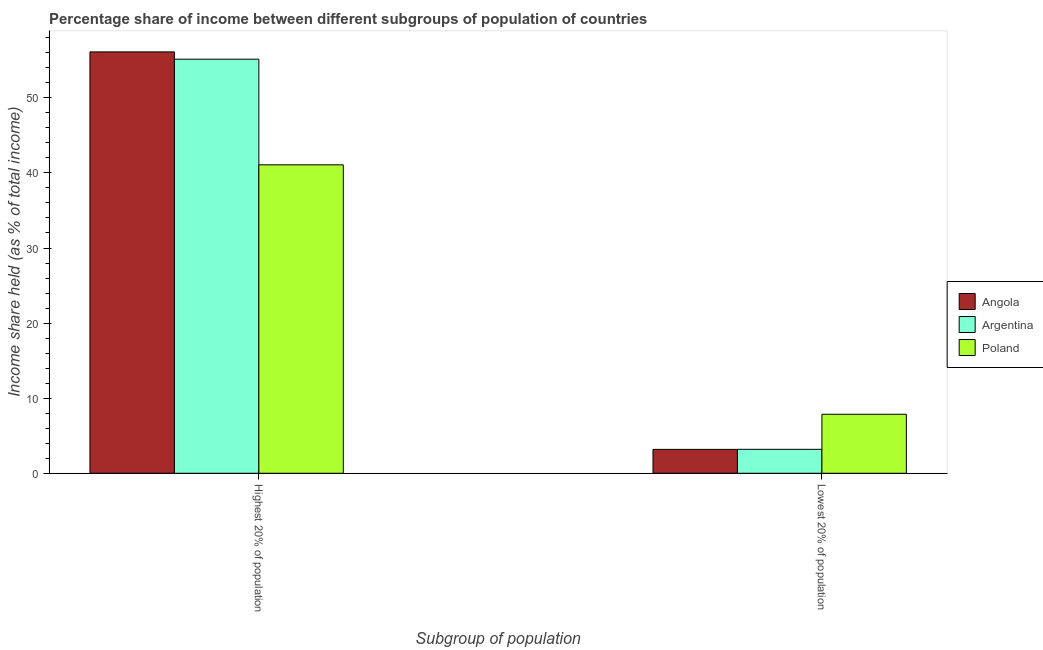How many groups of bars are there?
Make the answer very short. 2. Are the number of bars on each tick of the X-axis equal?
Provide a short and direct response. Yes. How many bars are there on the 1st tick from the right?
Your response must be concise. 3. What is the label of the 2nd group of bars from the left?
Your response must be concise. Lowest 20% of population. What is the income share held by lowest 20% of the population in Angola?
Provide a short and direct response. 3.18. Across all countries, what is the maximum income share held by lowest 20% of the population?
Provide a short and direct response. 7.86. Across all countries, what is the minimum income share held by highest 20% of the population?
Offer a very short reply. 41.08. In which country was the income share held by lowest 20% of the population maximum?
Your response must be concise. Poland. In which country was the income share held by lowest 20% of the population minimum?
Provide a succinct answer. Angola. What is the total income share held by lowest 20% of the population in the graph?
Offer a terse response. 14.23. What is the difference between the income share held by lowest 20% of the population in Argentina and that in Poland?
Ensure brevity in your answer.  -4.67. What is the difference between the income share held by lowest 20% of the population in Poland and the income share held by highest 20% of the population in Argentina?
Your response must be concise. -47.29. What is the average income share held by lowest 20% of the population per country?
Give a very brief answer. 4.74. What is the difference between the income share held by highest 20% of the population and income share held by lowest 20% of the population in Poland?
Provide a short and direct response. 33.22. What is the ratio of the income share held by lowest 20% of the population in Poland to that in Angola?
Provide a succinct answer. 2.47. Are all the bars in the graph horizontal?
Offer a very short reply. No. Are the values on the major ticks of Y-axis written in scientific E-notation?
Your answer should be very brief. No. How many legend labels are there?
Make the answer very short. 3. What is the title of the graph?
Provide a short and direct response. Percentage share of income between different subgroups of population of countries. What is the label or title of the X-axis?
Keep it short and to the point. Subgroup of population. What is the label or title of the Y-axis?
Provide a succinct answer. Income share held (as % of total income). What is the Income share held (as % of total income) in Angola in Highest 20% of population?
Offer a terse response. 56.12. What is the Income share held (as % of total income) in Argentina in Highest 20% of population?
Ensure brevity in your answer.  55.15. What is the Income share held (as % of total income) in Poland in Highest 20% of population?
Offer a very short reply. 41.08. What is the Income share held (as % of total income) in Angola in Lowest 20% of population?
Your answer should be compact. 3.18. What is the Income share held (as % of total income) of Argentina in Lowest 20% of population?
Provide a short and direct response. 3.19. What is the Income share held (as % of total income) in Poland in Lowest 20% of population?
Give a very brief answer. 7.86. Across all Subgroup of population, what is the maximum Income share held (as % of total income) in Angola?
Make the answer very short. 56.12. Across all Subgroup of population, what is the maximum Income share held (as % of total income) of Argentina?
Your answer should be very brief. 55.15. Across all Subgroup of population, what is the maximum Income share held (as % of total income) of Poland?
Make the answer very short. 41.08. Across all Subgroup of population, what is the minimum Income share held (as % of total income) of Angola?
Ensure brevity in your answer.  3.18. Across all Subgroup of population, what is the minimum Income share held (as % of total income) in Argentina?
Your answer should be compact. 3.19. Across all Subgroup of population, what is the minimum Income share held (as % of total income) in Poland?
Your response must be concise. 7.86. What is the total Income share held (as % of total income) of Angola in the graph?
Offer a very short reply. 59.3. What is the total Income share held (as % of total income) of Argentina in the graph?
Provide a succinct answer. 58.34. What is the total Income share held (as % of total income) of Poland in the graph?
Keep it short and to the point. 48.94. What is the difference between the Income share held (as % of total income) in Angola in Highest 20% of population and that in Lowest 20% of population?
Ensure brevity in your answer.  52.94. What is the difference between the Income share held (as % of total income) of Argentina in Highest 20% of population and that in Lowest 20% of population?
Provide a short and direct response. 51.96. What is the difference between the Income share held (as % of total income) of Poland in Highest 20% of population and that in Lowest 20% of population?
Offer a terse response. 33.22. What is the difference between the Income share held (as % of total income) in Angola in Highest 20% of population and the Income share held (as % of total income) in Argentina in Lowest 20% of population?
Make the answer very short. 52.93. What is the difference between the Income share held (as % of total income) of Angola in Highest 20% of population and the Income share held (as % of total income) of Poland in Lowest 20% of population?
Ensure brevity in your answer.  48.26. What is the difference between the Income share held (as % of total income) of Argentina in Highest 20% of population and the Income share held (as % of total income) of Poland in Lowest 20% of population?
Keep it short and to the point. 47.29. What is the average Income share held (as % of total income) in Angola per Subgroup of population?
Offer a terse response. 29.65. What is the average Income share held (as % of total income) of Argentina per Subgroup of population?
Your response must be concise. 29.17. What is the average Income share held (as % of total income) in Poland per Subgroup of population?
Your answer should be compact. 24.47. What is the difference between the Income share held (as % of total income) of Angola and Income share held (as % of total income) of Argentina in Highest 20% of population?
Offer a terse response. 0.97. What is the difference between the Income share held (as % of total income) of Angola and Income share held (as % of total income) of Poland in Highest 20% of population?
Your answer should be compact. 15.04. What is the difference between the Income share held (as % of total income) of Argentina and Income share held (as % of total income) of Poland in Highest 20% of population?
Make the answer very short. 14.07. What is the difference between the Income share held (as % of total income) of Angola and Income share held (as % of total income) of Argentina in Lowest 20% of population?
Ensure brevity in your answer.  -0.01. What is the difference between the Income share held (as % of total income) in Angola and Income share held (as % of total income) in Poland in Lowest 20% of population?
Give a very brief answer. -4.68. What is the difference between the Income share held (as % of total income) in Argentina and Income share held (as % of total income) in Poland in Lowest 20% of population?
Your response must be concise. -4.67. What is the ratio of the Income share held (as % of total income) in Angola in Highest 20% of population to that in Lowest 20% of population?
Your answer should be very brief. 17.65. What is the ratio of the Income share held (as % of total income) of Argentina in Highest 20% of population to that in Lowest 20% of population?
Give a very brief answer. 17.29. What is the ratio of the Income share held (as % of total income) in Poland in Highest 20% of population to that in Lowest 20% of population?
Your answer should be compact. 5.23. What is the difference between the highest and the second highest Income share held (as % of total income) in Angola?
Ensure brevity in your answer.  52.94. What is the difference between the highest and the second highest Income share held (as % of total income) of Argentina?
Your answer should be compact. 51.96. What is the difference between the highest and the second highest Income share held (as % of total income) in Poland?
Provide a short and direct response. 33.22. What is the difference between the highest and the lowest Income share held (as % of total income) of Angola?
Offer a very short reply. 52.94. What is the difference between the highest and the lowest Income share held (as % of total income) of Argentina?
Your response must be concise. 51.96. What is the difference between the highest and the lowest Income share held (as % of total income) of Poland?
Give a very brief answer. 33.22. 